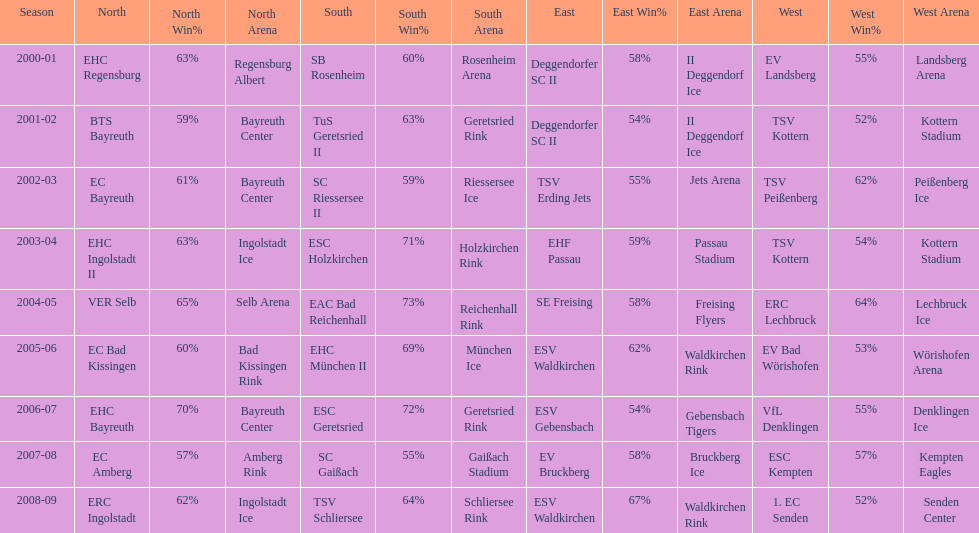Who won the south after esc geretsried did during the 2006-07 season? SC Gaißach. 